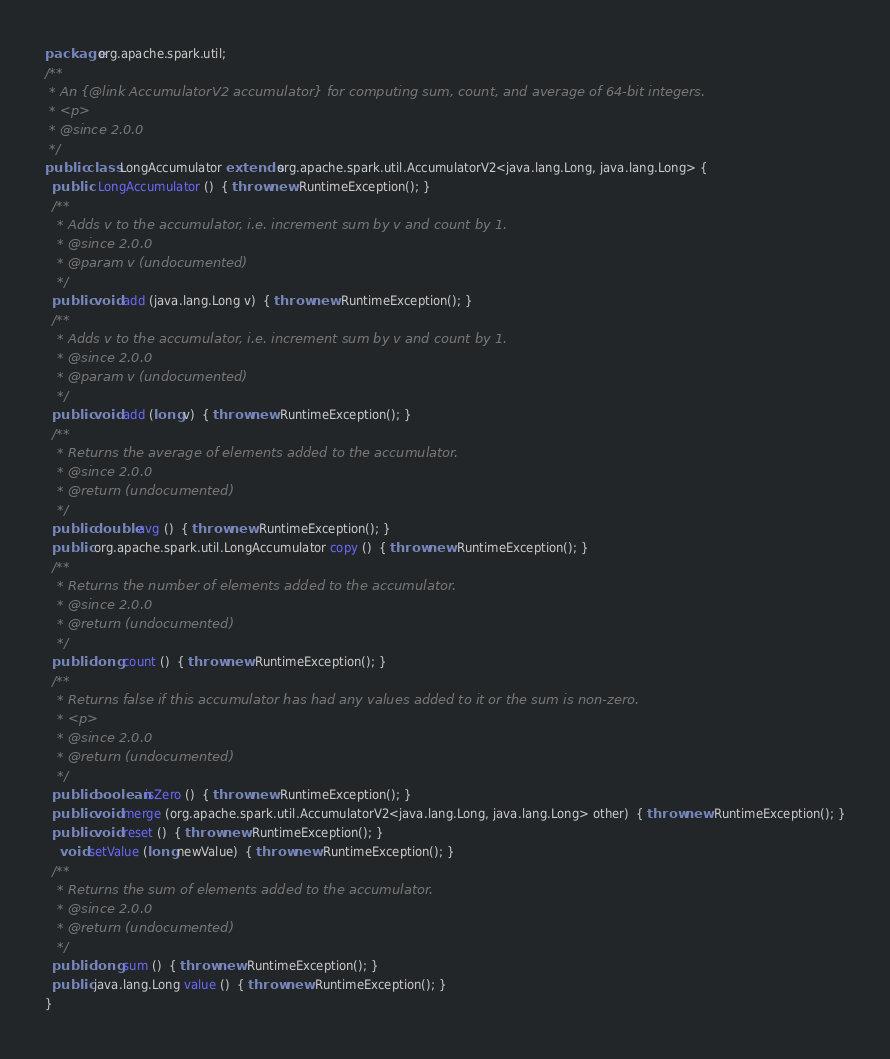<code> <loc_0><loc_0><loc_500><loc_500><_Java_>package org.apache.spark.util;
/**
 * An {@link AccumulatorV2 accumulator} for computing sum, count, and average of 64-bit integers.
 * <p>
 * @since 2.0.0
 */
public  class LongAccumulator extends org.apache.spark.util.AccumulatorV2<java.lang.Long, java.lang.Long> {
  public   LongAccumulator ()  { throw new RuntimeException(); }
  /**
   * Adds v to the accumulator, i.e. increment sum by v and count by 1.
   * @since 2.0.0
   * @param v (undocumented)
   */
  public  void add (java.lang.Long v)  { throw new RuntimeException(); }
  /**
   * Adds v to the accumulator, i.e. increment sum by v and count by 1.
   * @since 2.0.0
   * @param v (undocumented)
   */
  public  void add (long v)  { throw new RuntimeException(); }
  /**
   * Returns the average of elements added to the accumulator.
   * @since 2.0.0
   * @return (undocumented)
   */
  public  double avg ()  { throw new RuntimeException(); }
  public  org.apache.spark.util.LongAccumulator copy ()  { throw new RuntimeException(); }
  /**
   * Returns the number of elements added to the accumulator.
   * @since 2.0.0
   * @return (undocumented)
   */
  public  long count ()  { throw new RuntimeException(); }
  /**
   * Returns false if this accumulator has had any values added to it or the sum is non-zero.
   * <p>
   * @since 2.0.0
   * @return (undocumented)
   */
  public  boolean isZero ()  { throw new RuntimeException(); }
  public  void merge (org.apache.spark.util.AccumulatorV2<java.lang.Long, java.lang.Long> other)  { throw new RuntimeException(); }
  public  void reset ()  { throw new RuntimeException(); }
    void setValue (long newValue)  { throw new RuntimeException(); }
  /**
   * Returns the sum of elements added to the accumulator.
   * @since 2.0.0
   * @return (undocumented)
   */
  public  long sum ()  { throw new RuntimeException(); }
  public  java.lang.Long value ()  { throw new RuntimeException(); }
}
</code> 